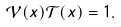Convert formula to latex. <formula><loc_0><loc_0><loc_500><loc_500>\mathcal { V } ( x ) \mathcal { T } ( x ) = 1 .</formula> 